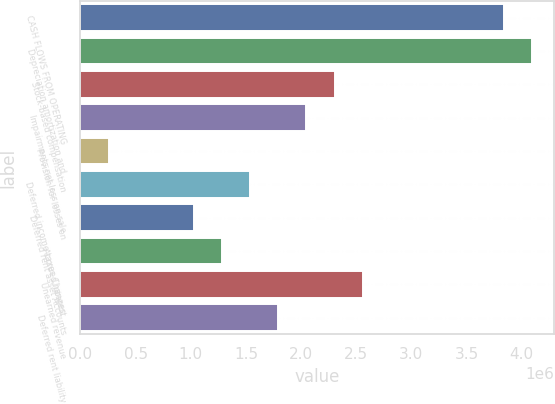Convert chart to OTSL. <chart><loc_0><loc_0><loc_500><loc_500><bar_chart><fcel>CASH FLOWS FROM OPERATING<fcel>Depreciation amortization and<fcel>Stock-based compensation<fcel>Impairments net loss on sale<fcel>Provision for losses on<fcel>Deferred income taxes Changes<fcel>Deferred rent asset Accounts<fcel>Accrued interest<fcel>Unearned revenue<fcel>Deferred rent liability<nl><fcel>3.83494e+06<fcel>4.09024e+06<fcel>2.30308e+06<fcel>2.04776e+06<fcel>260595<fcel>1.53714e+06<fcel>1.02652e+06<fcel>1.28184e+06<fcel>2.55838e+06<fcel>1.79246e+06<nl></chart> 